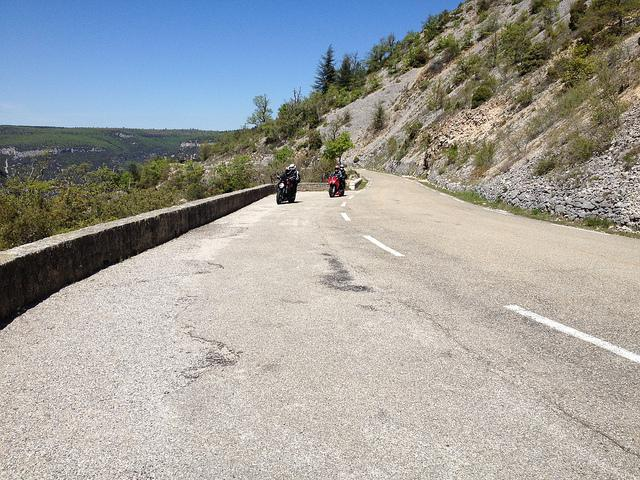What color is the vehicle on the right?

Choices:
A) red
B) green
C) blue
D) purple red 